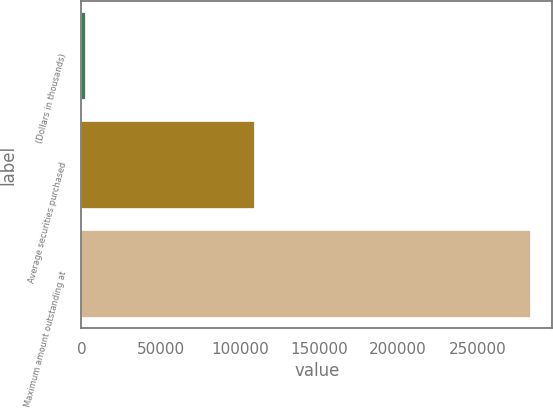Convert chart to OTSL. <chart><loc_0><loc_0><loc_500><loc_500><bar_chart><fcel>(Dollars in thousands)<fcel>Average securities purchased<fcel>Maximum amount outstanding at<nl><fcel>2014<fcel>108910<fcel>283215<nl></chart> 